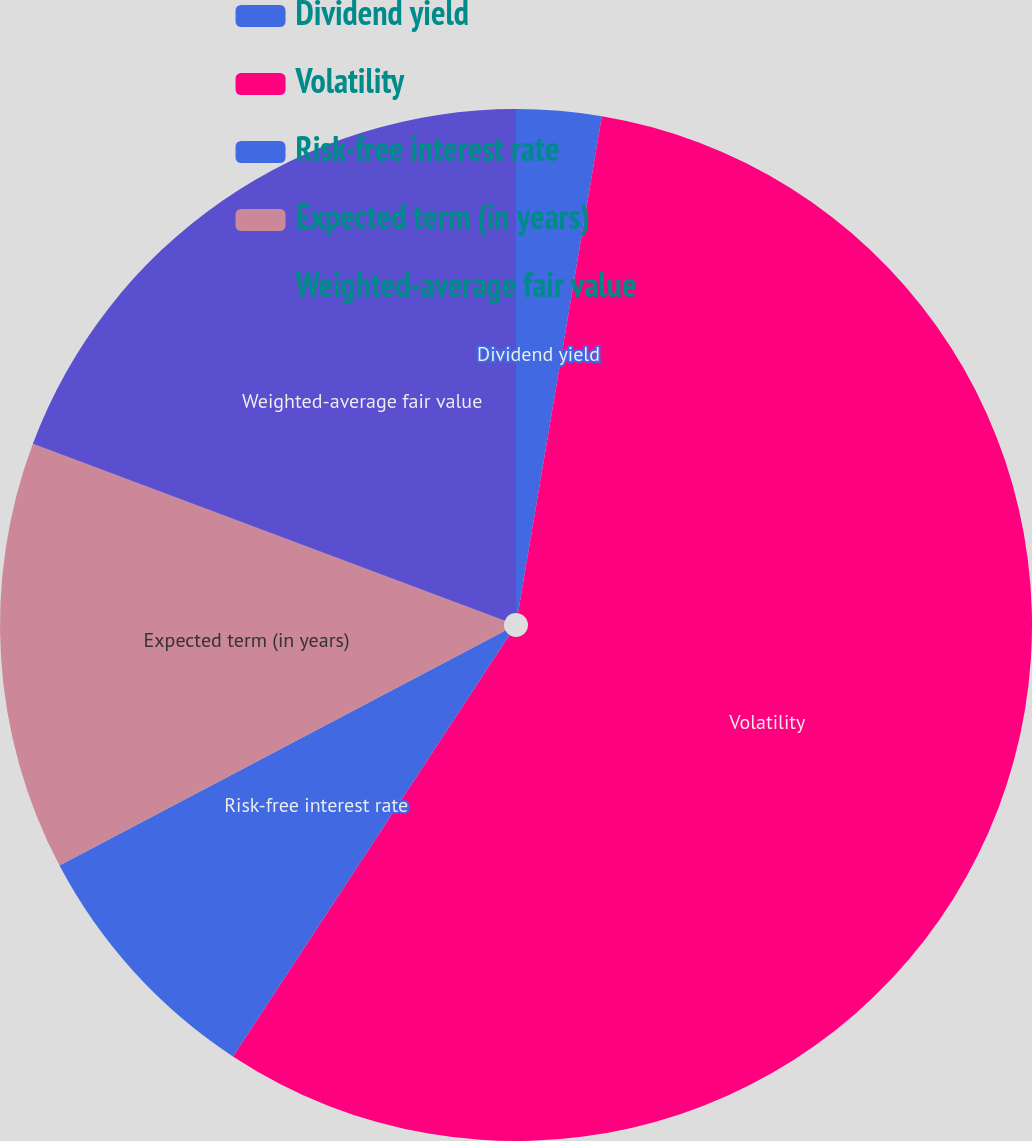Convert chart to OTSL. <chart><loc_0><loc_0><loc_500><loc_500><pie_chart><fcel>Dividend yield<fcel>Volatility<fcel>Risk-free interest rate<fcel>Expected term (in years)<fcel>Weighted-average fair value<nl><fcel>2.66%<fcel>56.58%<fcel>8.04%<fcel>13.43%<fcel>19.29%<nl></chart> 